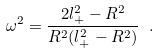<formula> <loc_0><loc_0><loc_500><loc_500>\omega ^ { 2 } = \frac { 2 l _ { + } ^ { 2 } - R ^ { 2 } } { R ^ { 2 } ( l _ { + } ^ { 2 } - R ^ { 2 } ) } \ .</formula> 